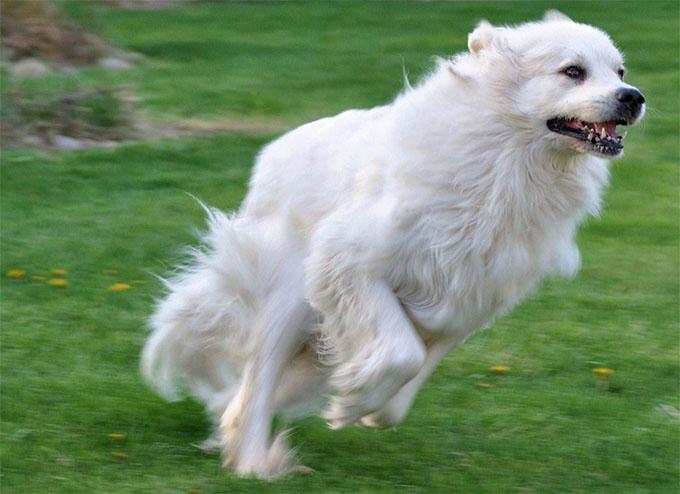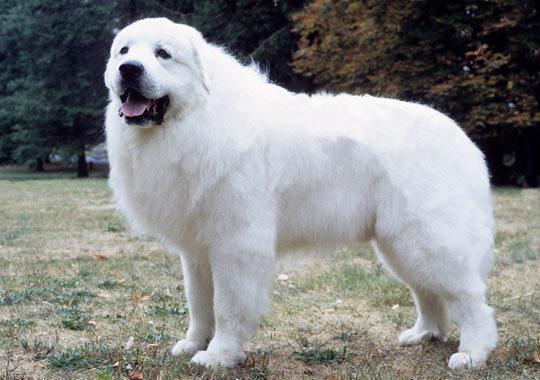The first image is the image on the left, the second image is the image on the right. Analyze the images presented: Is the assertion "There are a total of three dogs, and there are more dogs in the left image." valid? Answer yes or no. No. The first image is the image on the left, the second image is the image on the right. For the images displayed, is the sentence "An image shows one big white dog, standing with its head and body turned rightwards." factually correct? Answer yes or no. No. The first image is the image on the left, the second image is the image on the right. Assess this claim about the two images: "At least one of the dogs has a collar and tag clearly visible around it's neck.". Correct or not? Answer yes or no. No. The first image is the image on the left, the second image is the image on the right. Analyze the images presented: Is the assertion "At least one dog is standing in the grass." valid? Answer yes or no. Yes. The first image is the image on the left, the second image is the image on the right. For the images displayed, is the sentence "There is one dog facing right in the right image." factually correct? Answer yes or no. No. The first image is the image on the left, the second image is the image on the right. Assess this claim about the two images: "Exactly three large white dogs are shown in outdoor settings.". Correct or not? Answer yes or no. No. The first image is the image on the left, the second image is the image on the right. Evaluate the accuracy of this statement regarding the images: "The dog in the right image is facing right.". Is it true? Answer yes or no. No. The first image is the image on the left, the second image is the image on the right. Analyze the images presented: Is the assertion "The right image shows a white dog in profile with a nature backdrop." valid? Answer yes or no. Yes. 